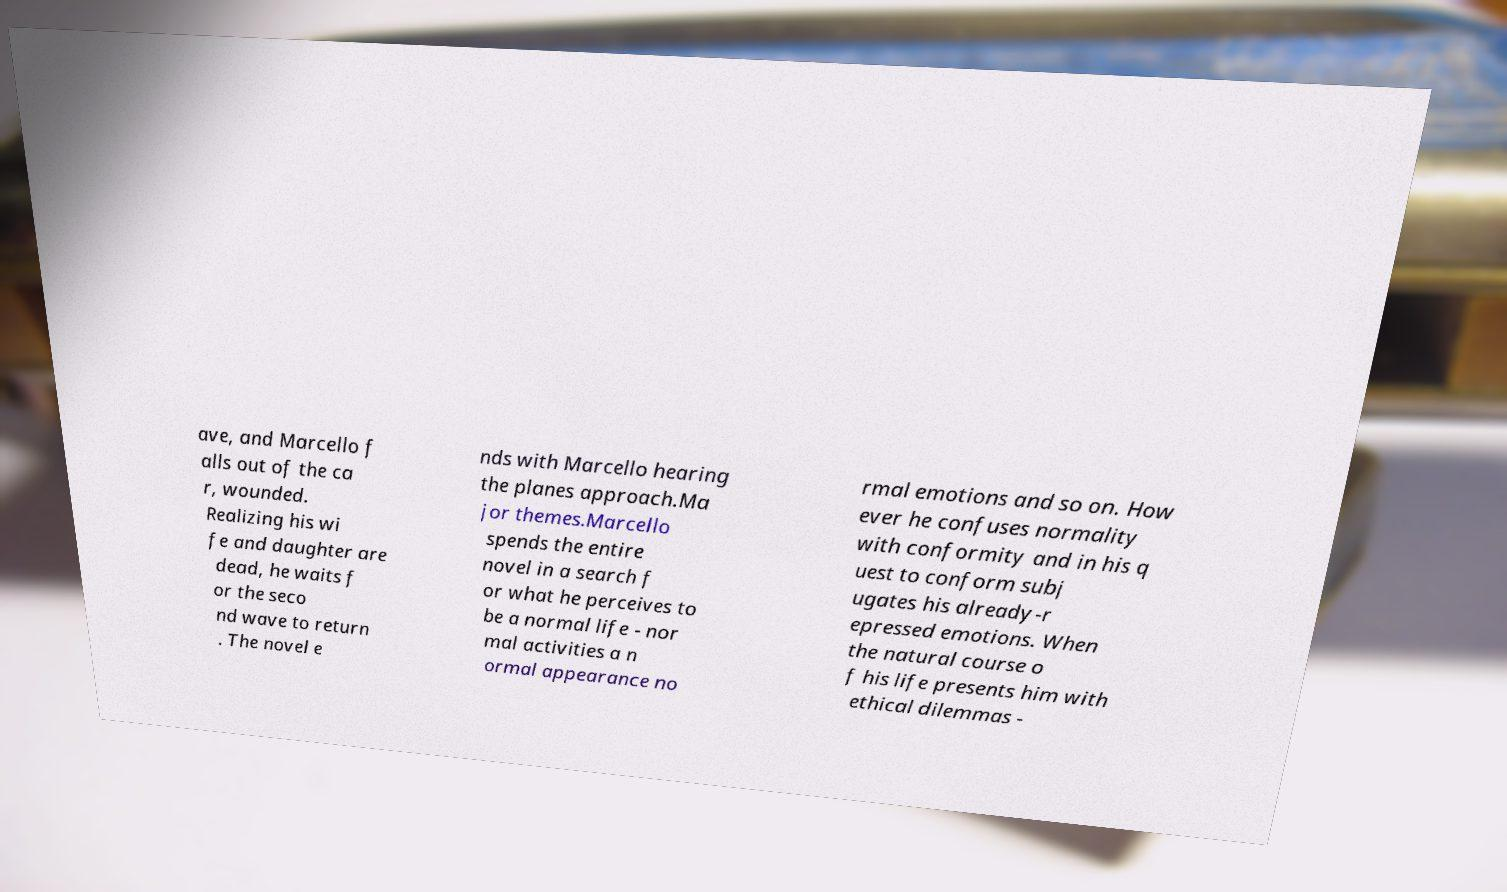Could you extract and type out the text from this image? ave, and Marcello f alls out of the ca r, wounded. Realizing his wi fe and daughter are dead, he waits f or the seco nd wave to return . The novel e nds with Marcello hearing the planes approach.Ma jor themes.Marcello spends the entire novel in a search f or what he perceives to be a normal life - nor mal activities a n ormal appearance no rmal emotions and so on. How ever he confuses normality with conformity and in his q uest to conform subj ugates his already-r epressed emotions. When the natural course o f his life presents him with ethical dilemmas - 